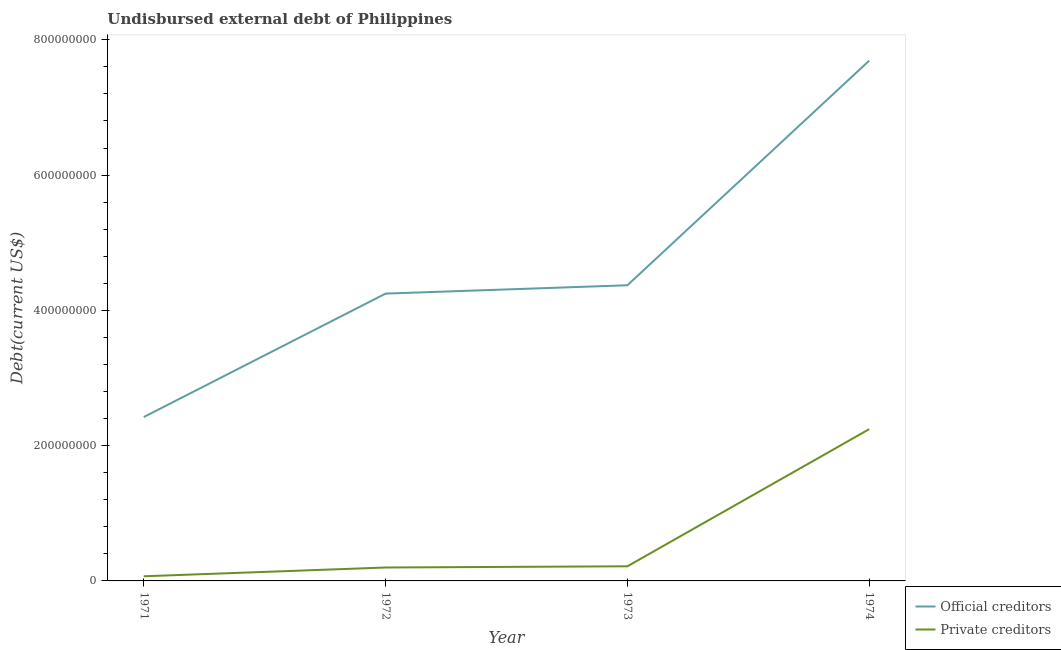Is the number of lines equal to the number of legend labels?
Provide a succinct answer. Yes. What is the undisbursed external debt of official creditors in 1971?
Make the answer very short. 2.42e+08. Across all years, what is the maximum undisbursed external debt of official creditors?
Your answer should be very brief. 7.69e+08. Across all years, what is the minimum undisbursed external debt of official creditors?
Keep it short and to the point. 2.42e+08. In which year was the undisbursed external debt of official creditors maximum?
Keep it short and to the point. 1974. In which year was the undisbursed external debt of private creditors minimum?
Give a very brief answer. 1971. What is the total undisbursed external debt of private creditors in the graph?
Your response must be concise. 2.73e+08. What is the difference between the undisbursed external debt of official creditors in 1973 and that in 1974?
Make the answer very short. -3.32e+08. What is the difference between the undisbursed external debt of official creditors in 1971 and the undisbursed external debt of private creditors in 1973?
Offer a terse response. 2.21e+08. What is the average undisbursed external debt of official creditors per year?
Give a very brief answer. 4.68e+08. In the year 1974, what is the difference between the undisbursed external debt of official creditors and undisbursed external debt of private creditors?
Make the answer very short. 5.45e+08. What is the ratio of the undisbursed external debt of private creditors in 1971 to that in 1974?
Your answer should be compact. 0.03. Is the difference between the undisbursed external debt of official creditors in 1973 and 1974 greater than the difference between the undisbursed external debt of private creditors in 1973 and 1974?
Offer a very short reply. No. What is the difference between the highest and the second highest undisbursed external debt of official creditors?
Make the answer very short. 3.32e+08. What is the difference between the highest and the lowest undisbursed external debt of official creditors?
Your response must be concise. 5.27e+08. In how many years, is the undisbursed external debt of private creditors greater than the average undisbursed external debt of private creditors taken over all years?
Keep it short and to the point. 1. Is the undisbursed external debt of private creditors strictly greater than the undisbursed external debt of official creditors over the years?
Provide a succinct answer. No. Is the undisbursed external debt of private creditors strictly less than the undisbursed external debt of official creditors over the years?
Offer a terse response. Yes. How many lines are there?
Offer a terse response. 2. Are the values on the major ticks of Y-axis written in scientific E-notation?
Provide a short and direct response. No. Does the graph contain any zero values?
Offer a very short reply. No. How many legend labels are there?
Make the answer very short. 2. How are the legend labels stacked?
Your answer should be compact. Vertical. What is the title of the graph?
Keep it short and to the point. Undisbursed external debt of Philippines. What is the label or title of the Y-axis?
Offer a very short reply. Debt(current US$). What is the Debt(current US$) in Official creditors in 1971?
Keep it short and to the point. 2.42e+08. What is the Debt(current US$) in Private creditors in 1971?
Provide a short and direct response. 6.87e+06. What is the Debt(current US$) in Official creditors in 1972?
Offer a very short reply. 4.25e+08. What is the Debt(current US$) in Private creditors in 1972?
Your response must be concise. 1.99e+07. What is the Debt(current US$) in Official creditors in 1973?
Provide a succinct answer. 4.37e+08. What is the Debt(current US$) of Private creditors in 1973?
Provide a short and direct response. 2.16e+07. What is the Debt(current US$) in Official creditors in 1974?
Give a very brief answer. 7.69e+08. What is the Debt(current US$) in Private creditors in 1974?
Give a very brief answer. 2.24e+08. Across all years, what is the maximum Debt(current US$) of Official creditors?
Offer a very short reply. 7.69e+08. Across all years, what is the maximum Debt(current US$) of Private creditors?
Provide a succinct answer. 2.24e+08. Across all years, what is the minimum Debt(current US$) of Official creditors?
Offer a terse response. 2.42e+08. Across all years, what is the minimum Debt(current US$) in Private creditors?
Provide a short and direct response. 6.87e+06. What is the total Debt(current US$) of Official creditors in the graph?
Your response must be concise. 1.87e+09. What is the total Debt(current US$) of Private creditors in the graph?
Keep it short and to the point. 2.73e+08. What is the difference between the Debt(current US$) of Official creditors in 1971 and that in 1972?
Make the answer very short. -1.83e+08. What is the difference between the Debt(current US$) of Private creditors in 1971 and that in 1972?
Offer a very short reply. -1.30e+07. What is the difference between the Debt(current US$) in Official creditors in 1971 and that in 1973?
Offer a terse response. -1.95e+08. What is the difference between the Debt(current US$) in Private creditors in 1971 and that in 1973?
Make the answer very short. -1.47e+07. What is the difference between the Debt(current US$) of Official creditors in 1971 and that in 1974?
Make the answer very short. -5.27e+08. What is the difference between the Debt(current US$) in Private creditors in 1971 and that in 1974?
Provide a succinct answer. -2.17e+08. What is the difference between the Debt(current US$) in Official creditors in 1972 and that in 1973?
Ensure brevity in your answer.  -1.23e+07. What is the difference between the Debt(current US$) of Private creditors in 1972 and that in 1973?
Make the answer very short. -1.76e+06. What is the difference between the Debt(current US$) in Official creditors in 1972 and that in 1974?
Ensure brevity in your answer.  -3.44e+08. What is the difference between the Debt(current US$) in Private creditors in 1972 and that in 1974?
Offer a very short reply. -2.05e+08. What is the difference between the Debt(current US$) in Official creditors in 1973 and that in 1974?
Your answer should be compact. -3.32e+08. What is the difference between the Debt(current US$) of Private creditors in 1973 and that in 1974?
Your answer should be very brief. -2.03e+08. What is the difference between the Debt(current US$) in Official creditors in 1971 and the Debt(current US$) in Private creditors in 1972?
Offer a very short reply. 2.22e+08. What is the difference between the Debt(current US$) in Official creditors in 1971 and the Debt(current US$) in Private creditors in 1973?
Offer a terse response. 2.21e+08. What is the difference between the Debt(current US$) in Official creditors in 1971 and the Debt(current US$) in Private creditors in 1974?
Offer a terse response. 1.79e+07. What is the difference between the Debt(current US$) of Official creditors in 1972 and the Debt(current US$) of Private creditors in 1973?
Your answer should be compact. 4.03e+08. What is the difference between the Debt(current US$) of Official creditors in 1972 and the Debt(current US$) of Private creditors in 1974?
Provide a short and direct response. 2.00e+08. What is the difference between the Debt(current US$) of Official creditors in 1973 and the Debt(current US$) of Private creditors in 1974?
Provide a succinct answer. 2.13e+08. What is the average Debt(current US$) in Official creditors per year?
Provide a short and direct response. 4.68e+08. What is the average Debt(current US$) of Private creditors per year?
Make the answer very short. 6.82e+07. In the year 1971, what is the difference between the Debt(current US$) in Official creditors and Debt(current US$) in Private creditors?
Give a very brief answer. 2.35e+08. In the year 1972, what is the difference between the Debt(current US$) of Official creditors and Debt(current US$) of Private creditors?
Provide a succinct answer. 4.05e+08. In the year 1973, what is the difference between the Debt(current US$) in Official creditors and Debt(current US$) in Private creditors?
Offer a very short reply. 4.15e+08. In the year 1974, what is the difference between the Debt(current US$) of Official creditors and Debt(current US$) of Private creditors?
Keep it short and to the point. 5.45e+08. What is the ratio of the Debt(current US$) of Official creditors in 1971 to that in 1972?
Provide a succinct answer. 0.57. What is the ratio of the Debt(current US$) in Private creditors in 1971 to that in 1972?
Make the answer very short. 0.35. What is the ratio of the Debt(current US$) in Official creditors in 1971 to that in 1973?
Give a very brief answer. 0.55. What is the ratio of the Debt(current US$) in Private creditors in 1971 to that in 1973?
Keep it short and to the point. 0.32. What is the ratio of the Debt(current US$) in Official creditors in 1971 to that in 1974?
Your response must be concise. 0.32. What is the ratio of the Debt(current US$) in Private creditors in 1971 to that in 1974?
Offer a very short reply. 0.03. What is the ratio of the Debt(current US$) of Official creditors in 1972 to that in 1973?
Your response must be concise. 0.97. What is the ratio of the Debt(current US$) in Private creditors in 1972 to that in 1973?
Your response must be concise. 0.92. What is the ratio of the Debt(current US$) of Official creditors in 1972 to that in 1974?
Make the answer very short. 0.55. What is the ratio of the Debt(current US$) in Private creditors in 1972 to that in 1974?
Your response must be concise. 0.09. What is the ratio of the Debt(current US$) in Official creditors in 1973 to that in 1974?
Ensure brevity in your answer.  0.57. What is the ratio of the Debt(current US$) of Private creditors in 1973 to that in 1974?
Your response must be concise. 0.1. What is the difference between the highest and the second highest Debt(current US$) of Official creditors?
Your answer should be very brief. 3.32e+08. What is the difference between the highest and the second highest Debt(current US$) in Private creditors?
Offer a terse response. 2.03e+08. What is the difference between the highest and the lowest Debt(current US$) of Official creditors?
Keep it short and to the point. 5.27e+08. What is the difference between the highest and the lowest Debt(current US$) in Private creditors?
Keep it short and to the point. 2.17e+08. 